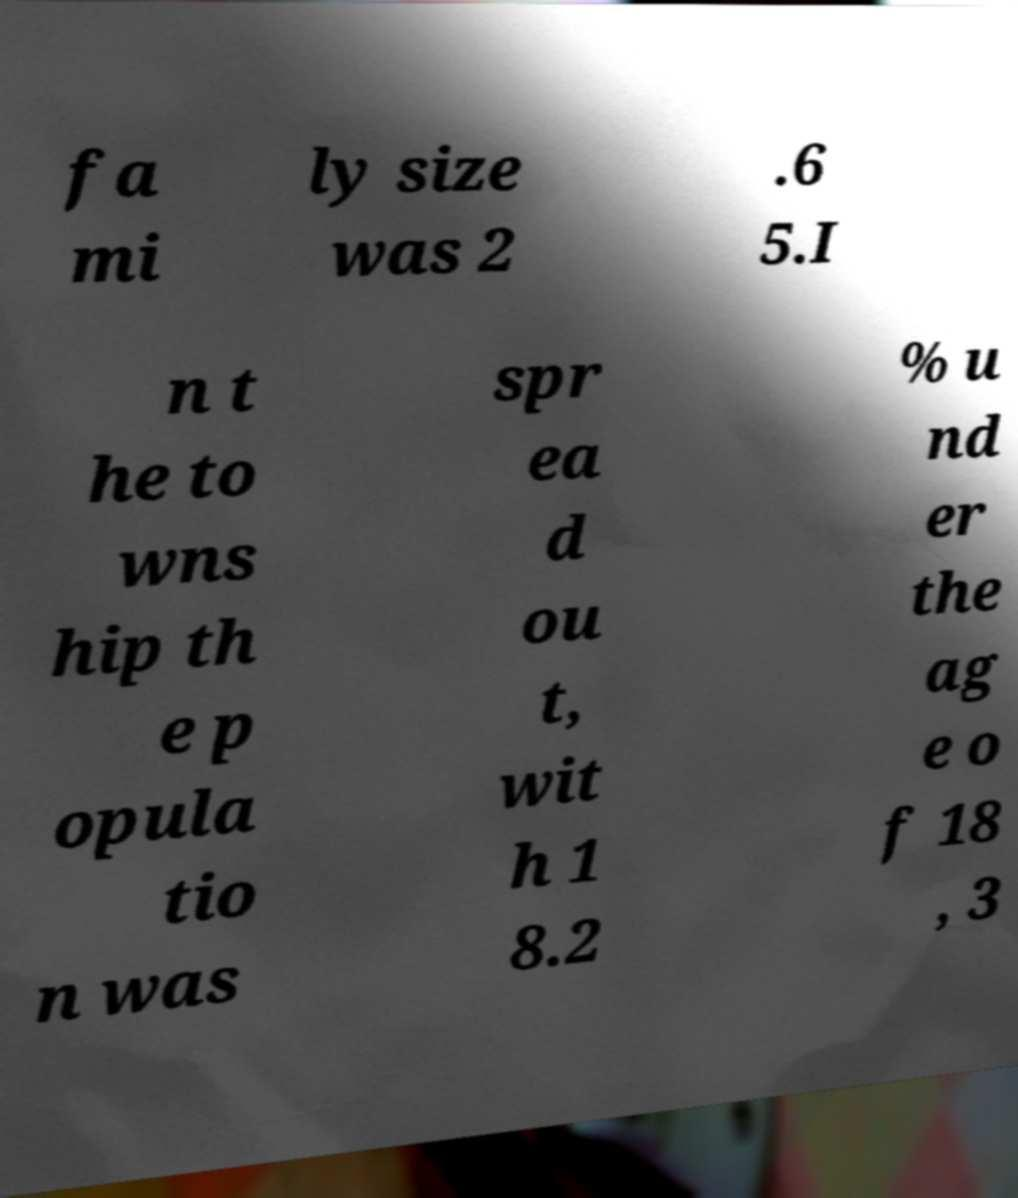Could you extract and type out the text from this image? fa mi ly size was 2 .6 5.I n t he to wns hip th e p opula tio n was spr ea d ou t, wit h 1 8.2 % u nd er the ag e o f 18 , 3 